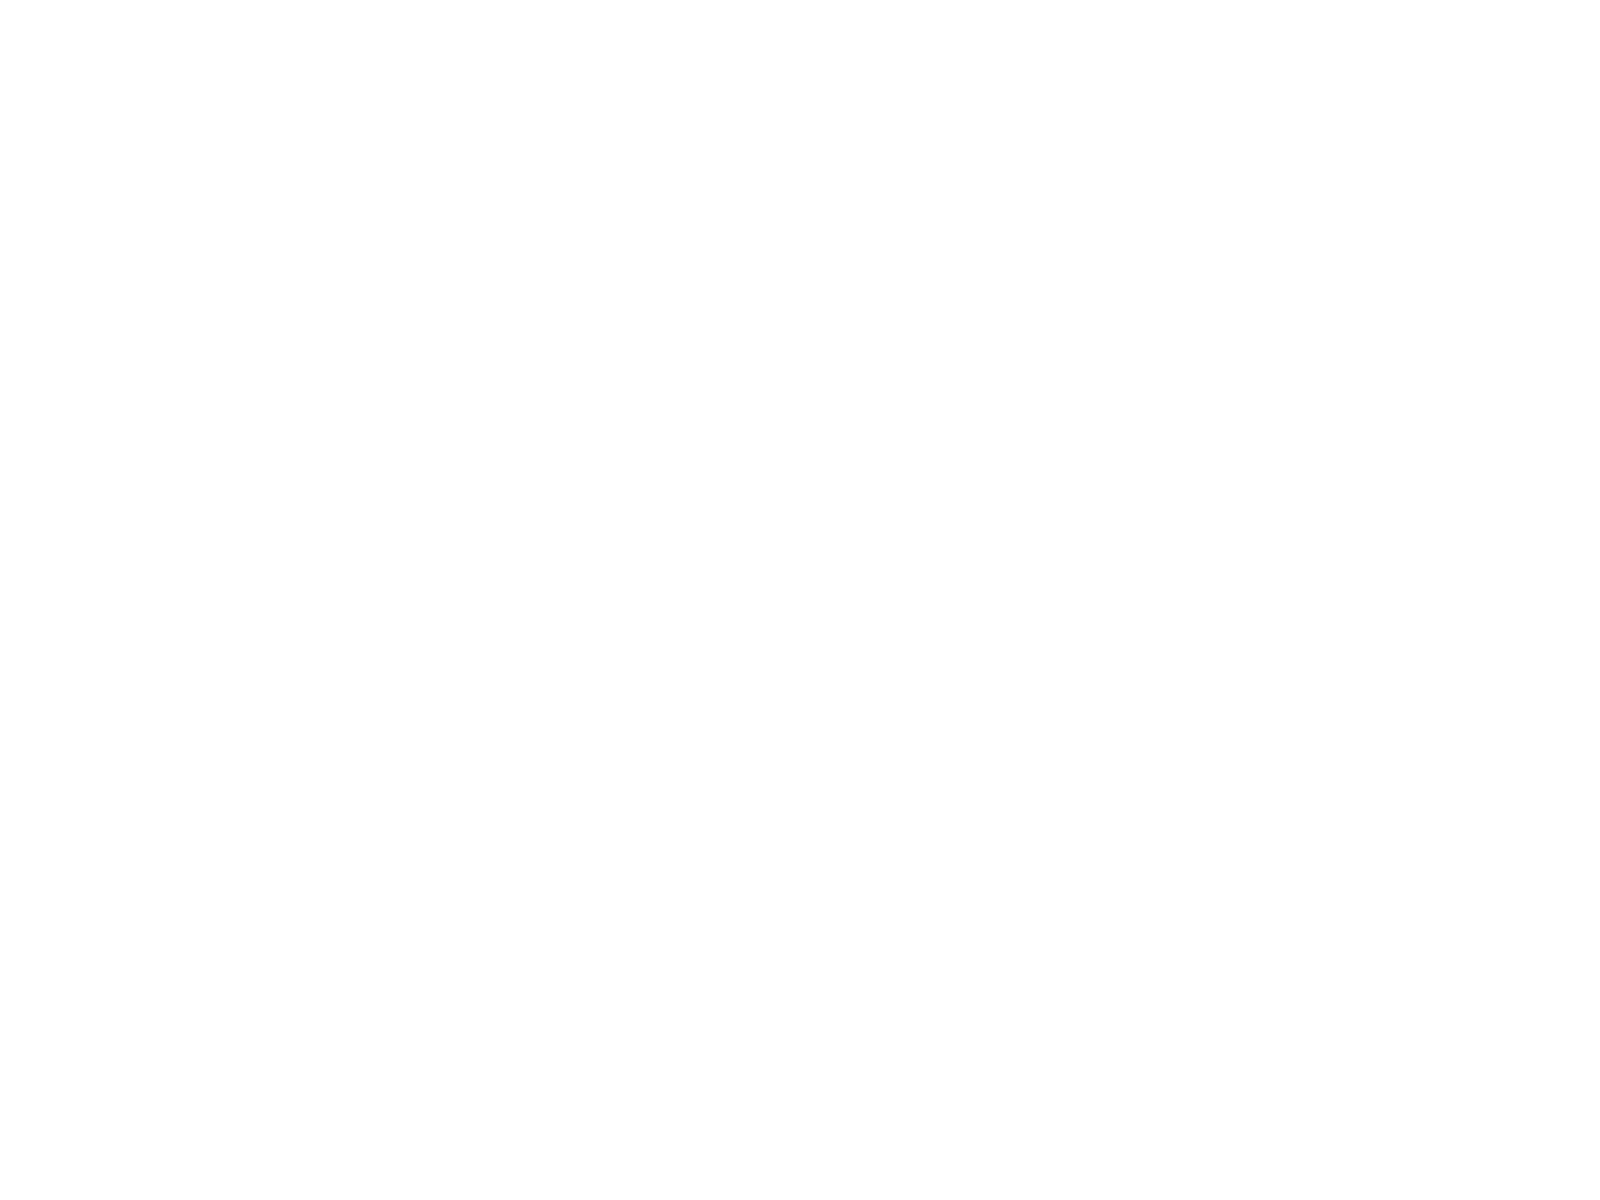Convert chart. <chart><loc_0><loc_0><loc_500><loc_500><pie_chart><fcel>Dollars in Millions<fcel>sanofi partnerships<fcel>Other<fcel>Noncontrolling<fcel>Income taxes<fcel>Net earnings from continuing<fcel>Net earnings attributable to<nl><fcel>23.76%<fcel>19.3%<fcel>0.29%<fcel>21.53%<fcel>6.32%<fcel>13.28%<fcel>15.51%<nl></chart> 